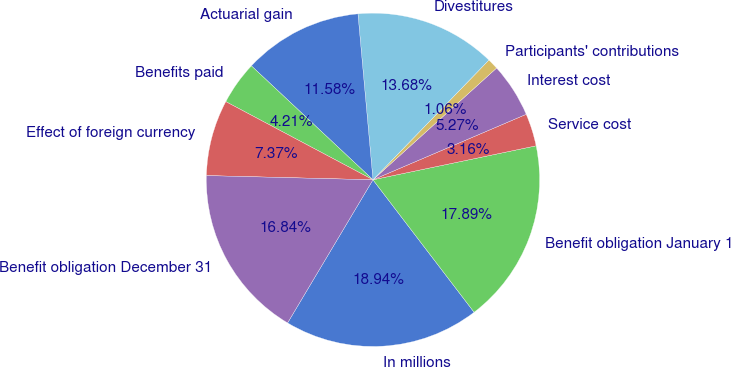Convert chart to OTSL. <chart><loc_0><loc_0><loc_500><loc_500><pie_chart><fcel>In millions<fcel>Benefit obligation January 1<fcel>Service cost<fcel>Interest cost<fcel>Participants' contributions<fcel>Divestitures<fcel>Actuarial gain<fcel>Benefits paid<fcel>Effect of foreign currency<fcel>Benefit obligation December 31<nl><fcel>18.94%<fcel>17.89%<fcel>3.16%<fcel>5.27%<fcel>1.06%<fcel>13.68%<fcel>11.58%<fcel>4.21%<fcel>7.37%<fcel>16.84%<nl></chart> 